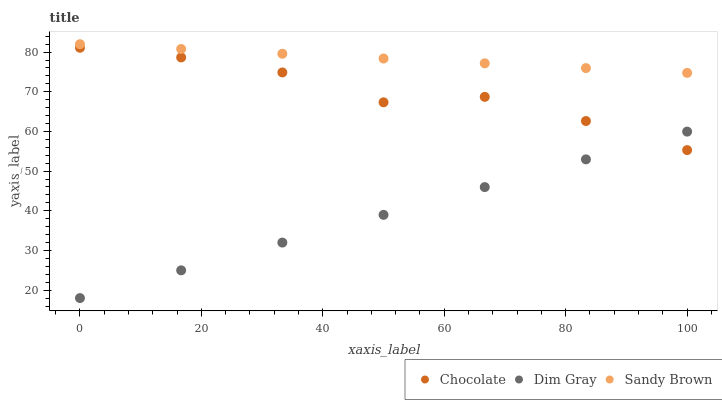Does Dim Gray have the minimum area under the curve?
Answer yes or no. Yes. Does Sandy Brown have the maximum area under the curve?
Answer yes or no. Yes. Does Chocolate have the minimum area under the curve?
Answer yes or no. No. Does Chocolate have the maximum area under the curve?
Answer yes or no. No. Is Sandy Brown the smoothest?
Answer yes or no. Yes. Is Chocolate the roughest?
Answer yes or no. Yes. Is Chocolate the smoothest?
Answer yes or no. No. Is Sandy Brown the roughest?
Answer yes or no. No. Does Dim Gray have the lowest value?
Answer yes or no. Yes. Does Chocolate have the lowest value?
Answer yes or no. No. Does Sandy Brown have the highest value?
Answer yes or no. Yes. Does Chocolate have the highest value?
Answer yes or no. No. Is Chocolate less than Sandy Brown?
Answer yes or no. Yes. Is Sandy Brown greater than Chocolate?
Answer yes or no. Yes. Does Chocolate intersect Dim Gray?
Answer yes or no. Yes. Is Chocolate less than Dim Gray?
Answer yes or no. No. Is Chocolate greater than Dim Gray?
Answer yes or no. No. Does Chocolate intersect Sandy Brown?
Answer yes or no. No. 